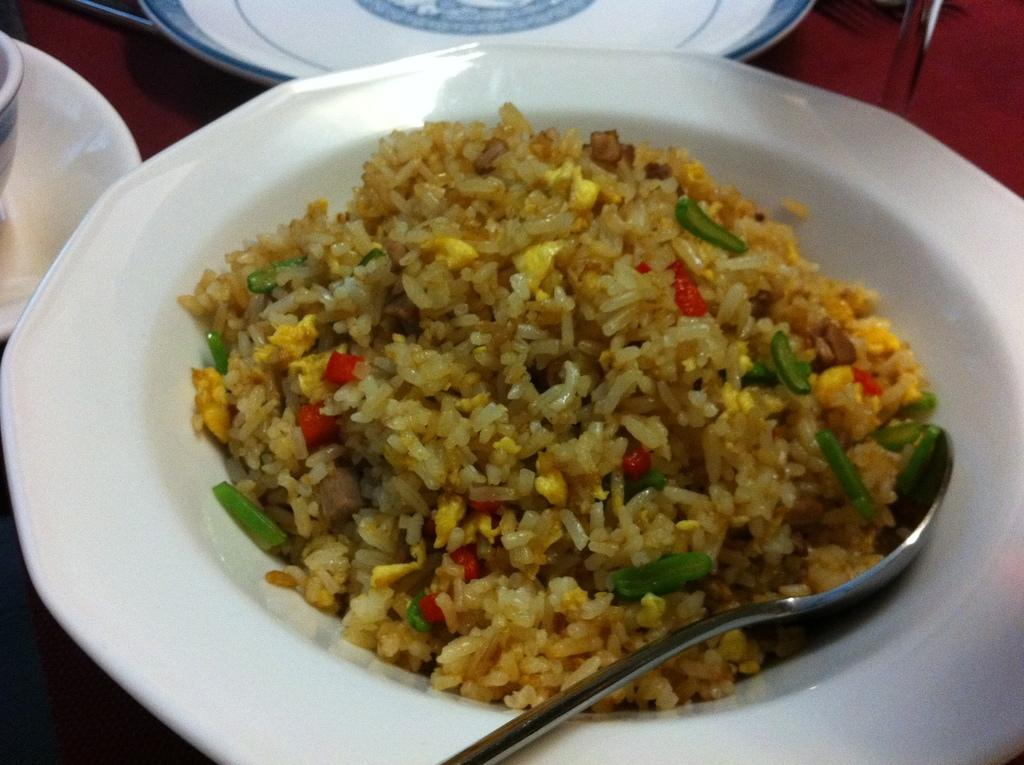What is the main object in the center of the image? There is a plate in the center of the image. What is on the plate? The plate contains rice. Can you describe any utensils in the image? There is a spoon at the bottom side of the image. What type of calculator is being used by the stranger in the image? There is no calculator or stranger present in the image; it only features a plate with rice and a spoon. 